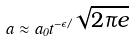<formula> <loc_0><loc_0><loc_500><loc_500>a \approx a _ { 0 } t ^ { - \epsilon / \sqrt { 2 \pi e } }</formula> 